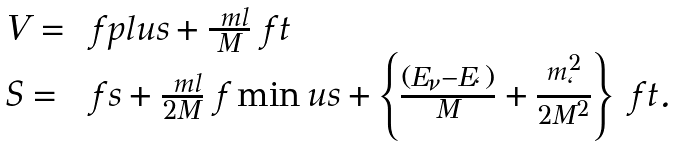Convert formula to latex. <formula><loc_0><loc_0><loc_500><loc_500>\begin{array} { l l } V = & \ f p l u s + \frac { \ m l } M \ f t \\ S = & \ f s + \frac { \ m l } { 2 M } \ f \min u s + \left \{ \frac { ( E _ { \nu } - E _ { \ell } ) } { M } + \frac { m _ { \ell } ^ { 2 } } { 2 M ^ { 2 } } \right \} \ f t . \end{array}</formula> 